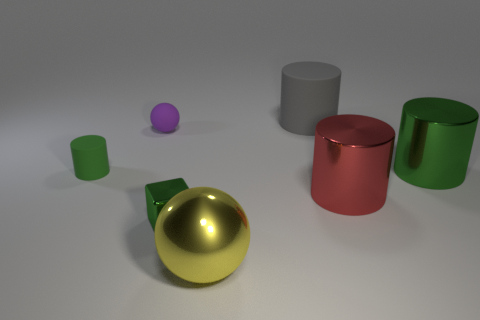What time of day does the lighting in the image suggest? The soft and diffused lighting in the image suggests an interior setting possibly lit by studio lighting, rather than natural light, which makes it difficult to determine a specific time of day. 